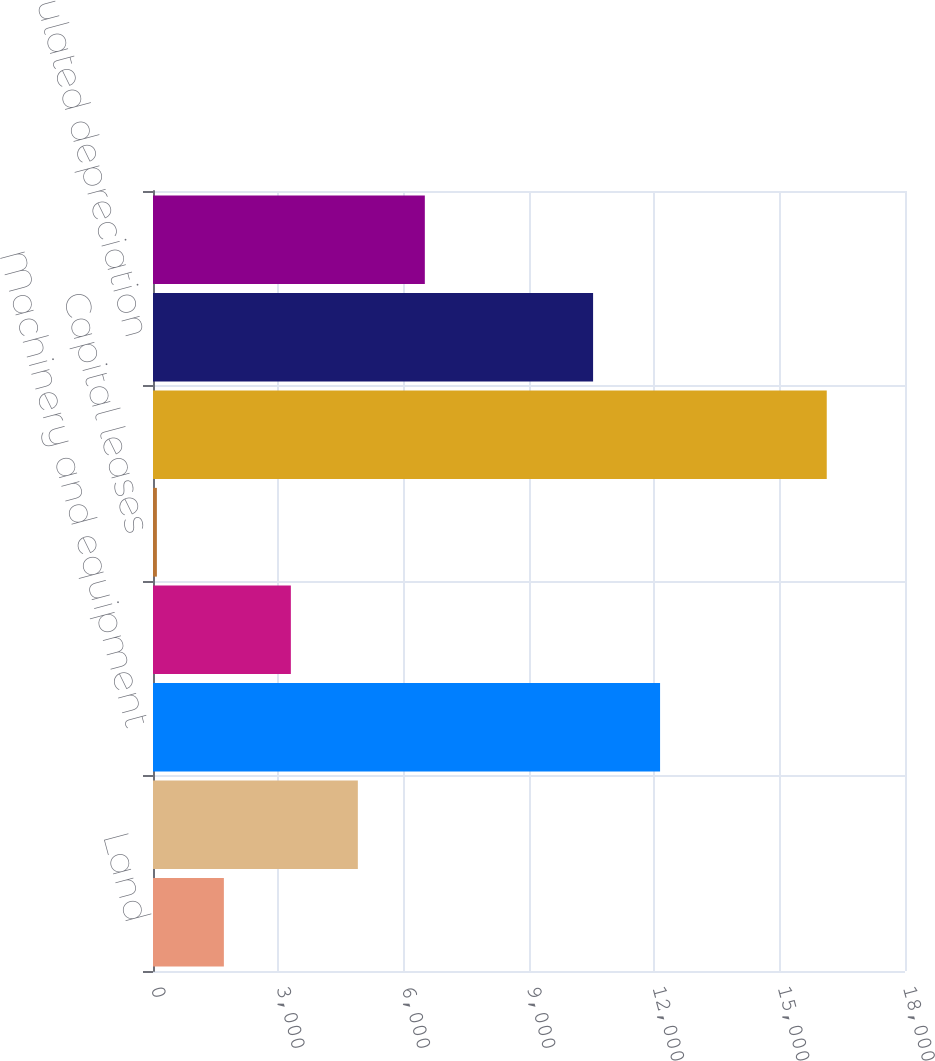Convert chart. <chart><loc_0><loc_0><loc_500><loc_500><bar_chart><fcel>Land<fcel>Buildings and leasehold<fcel>Machinery and equipment<fcel>Construction in progress<fcel>Capital leases<fcel>Gross property plant and<fcel>Accumulated depreciation<fcel>Property plant and equipment -<nl><fcel>1696.4<fcel>4903.2<fcel>12137.4<fcel>3299.8<fcel>93<fcel>16127<fcel>10534<fcel>6506.6<nl></chart> 